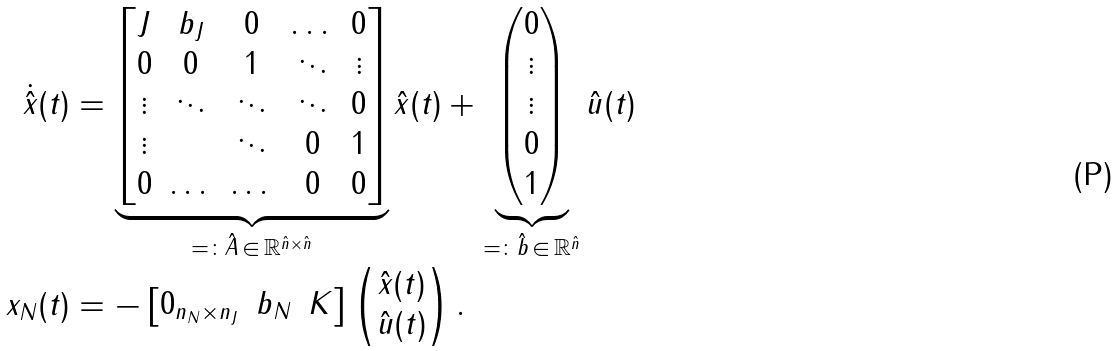Convert formula to latex. <formula><loc_0><loc_0><loc_500><loc_500>\dot { \hat { x } } ( t ) & = \underbrace { \begin{bmatrix} J & b _ { J } & 0 & \dots & 0 \\ 0 & 0 & 1 & \ddots & \vdots \\ \vdots & \ddots & \ddots & \ddots & 0 \\ \vdots & & \ddots & 0 & 1 \\ 0 & \dots & \dots & 0 & 0 \end{bmatrix} } _ { = \colon \hat { A } \, \in \, \mathbb { R } ^ { \hat { n } \times \hat { n } } } \hat { x } ( t ) + \underbrace { \begin{pmatrix} 0 \\ \vdots \\ \vdots \\ 0 \\ 1 \end{pmatrix} } _ { = \colon \hat { b } \, \in \, \mathbb { R } ^ { \hat { n } } } \hat { u } ( t ) \\ x _ { N } ( t ) & = - \begin{bmatrix} 0 _ { n _ { N } \times n _ { J } } & b _ { N } & K \end{bmatrix} \begin{pmatrix} \hat { x } ( t ) \\ \hat { u } ( t ) \end{pmatrix} .</formula> 